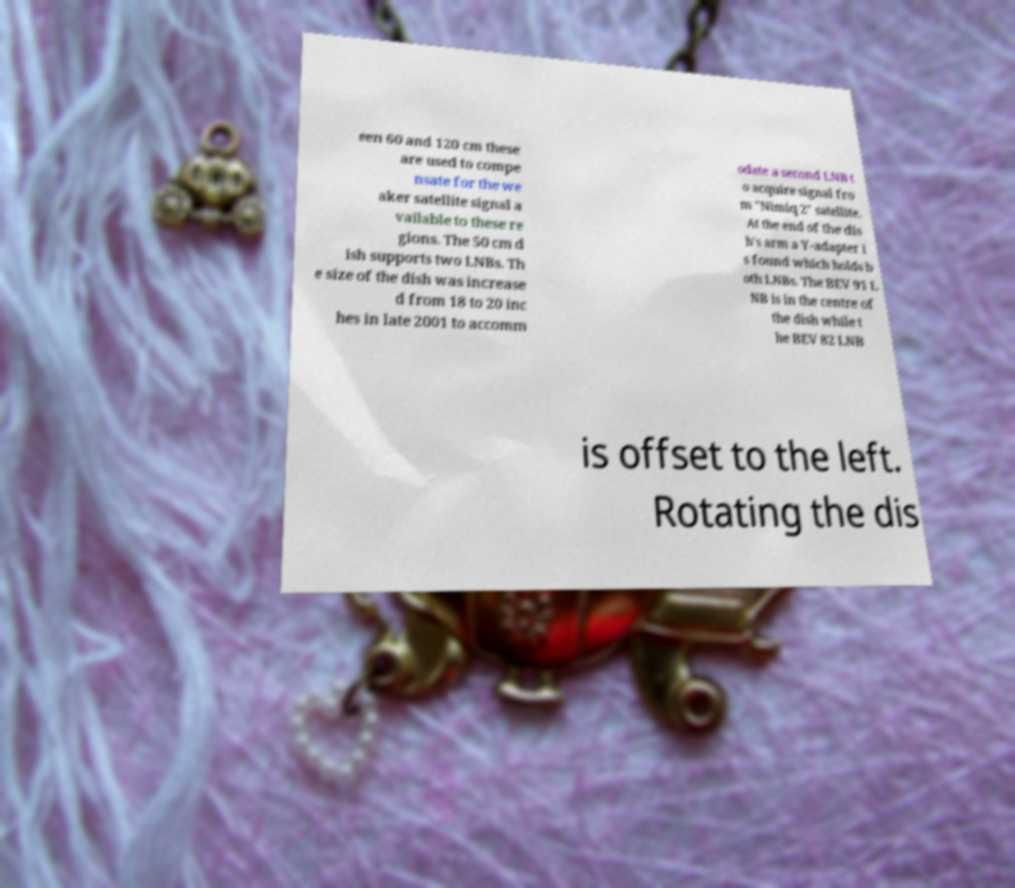Can you accurately transcribe the text from the provided image for me? een 60 and 120 cm these are used to compe nsate for the we aker satellite signal a vailable to these re gions. The 50 cm d ish supports two LNBs. Th e size of the dish was increase d from 18 to 20 inc hes in late 2001 to accomm odate a second LNB t o acquire signal fro m "Nimiq 2" satellite. At the end of the dis h's arm a Y-adapter i s found which holds b oth LNBs. The BEV 91 L NB is in the centre of the dish while t he BEV 82 LNB is offset to the left. Rotating the dis 